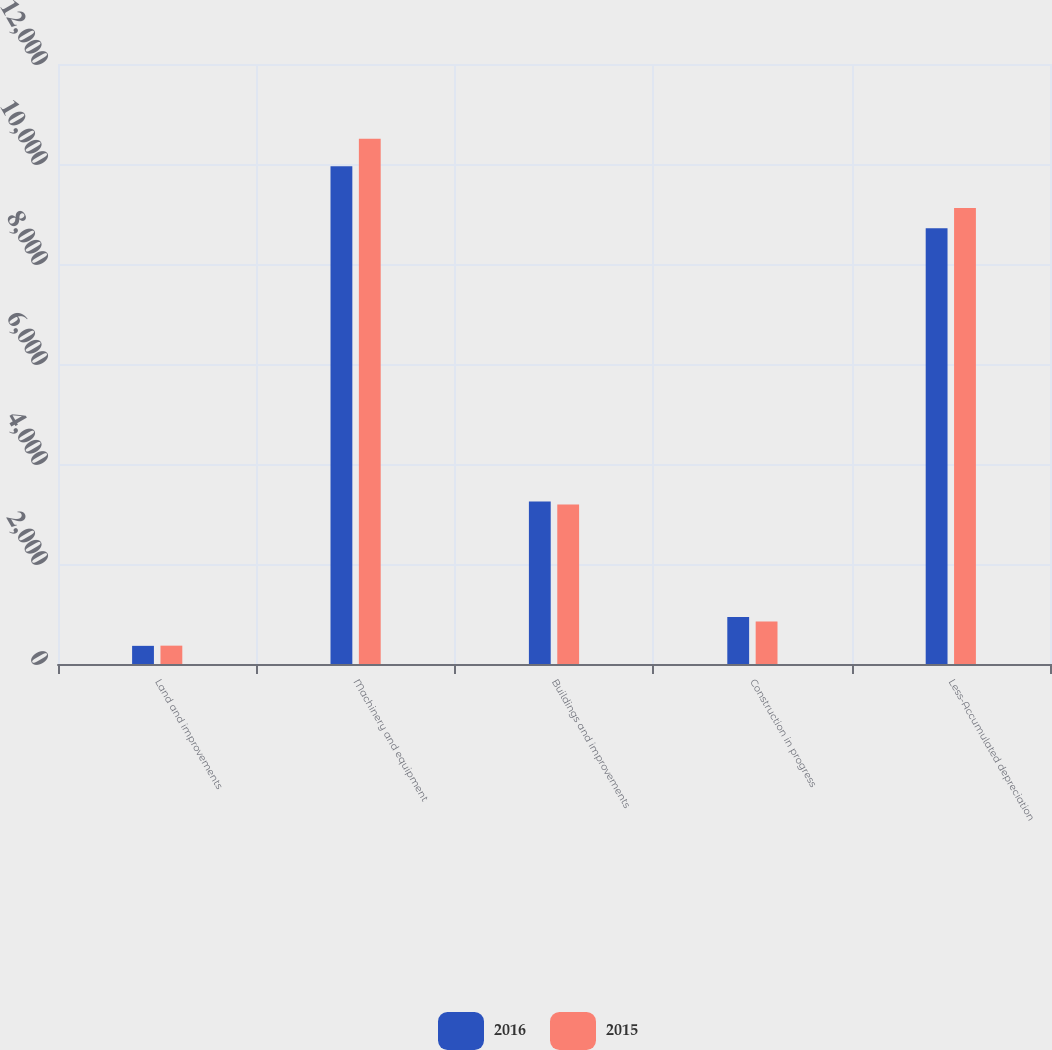<chart> <loc_0><loc_0><loc_500><loc_500><stacked_bar_chart><ecel><fcel>Land and improvements<fcel>Machinery and equipment<fcel>Buildings and improvements<fcel>Construction in progress<fcel>Less-Accumulated depreciation<nl><fcel>2016<fcel>363<fcel>9956<fcel>3248<fcel>940<fcel>8714<nl><fcel>2015<fcel>367<fcel>10505<fcel>3188<fcel>848<fcel>9119<nl></chart> 